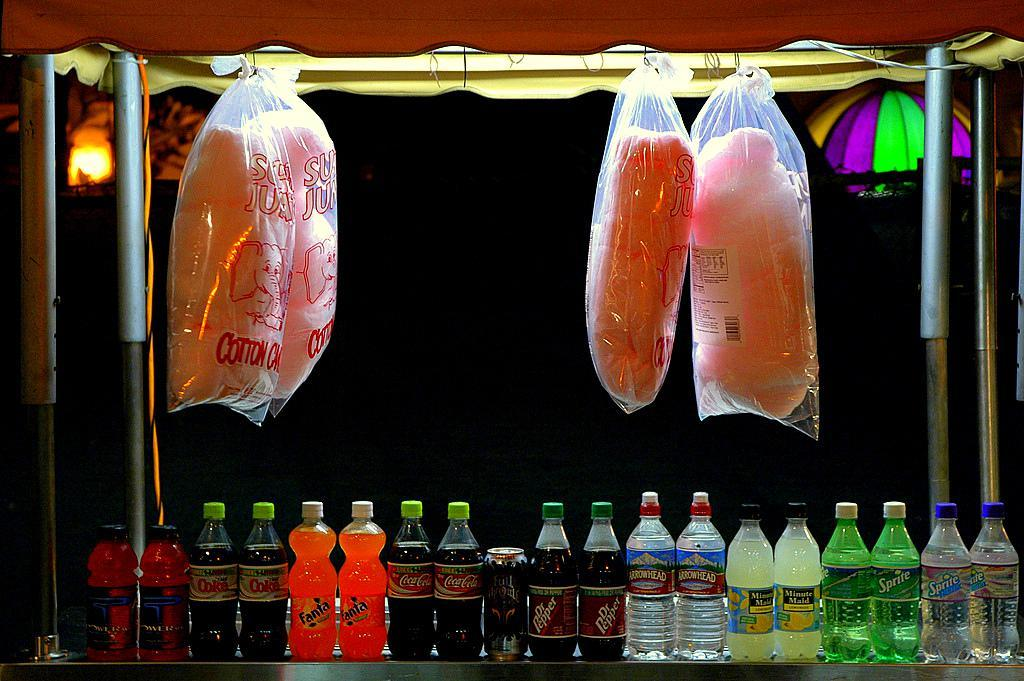What type of containers can be seen in the image? There are bottles and a tin in the image. What might be used to protect the contents of the containers? There are covers in the image. What can be seen in the background of the image? There is a light in the background of the image. What type of condition is the arch in the image? There is no arch present in the image. 